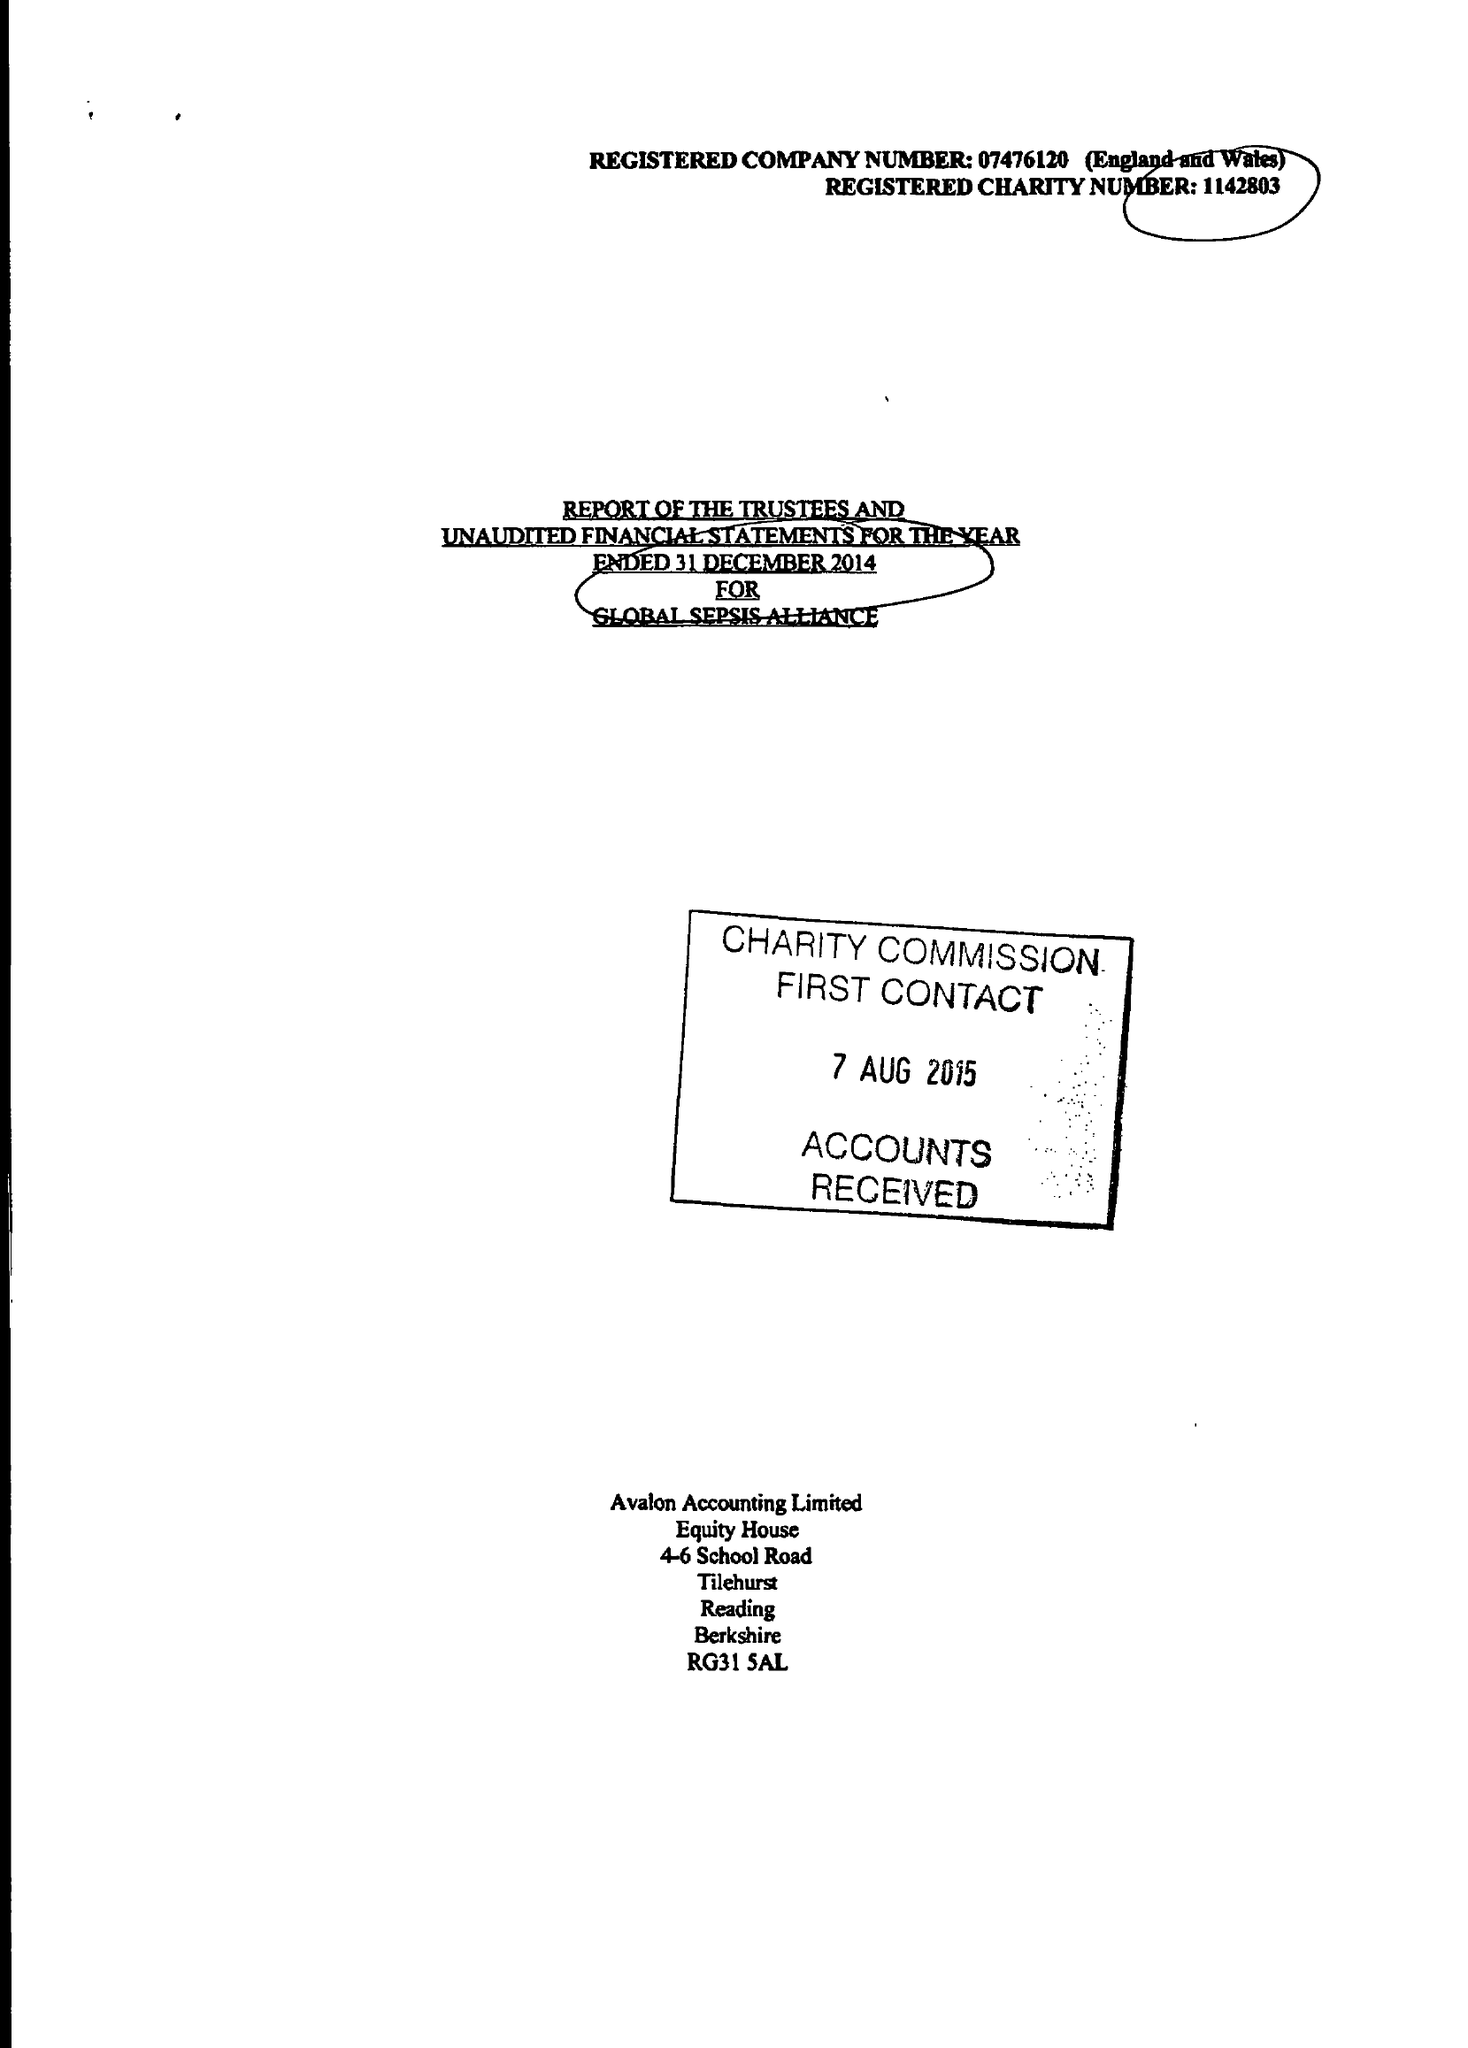What is the value for the address__post_town?
Answer the question using a single word or phrase. READING 